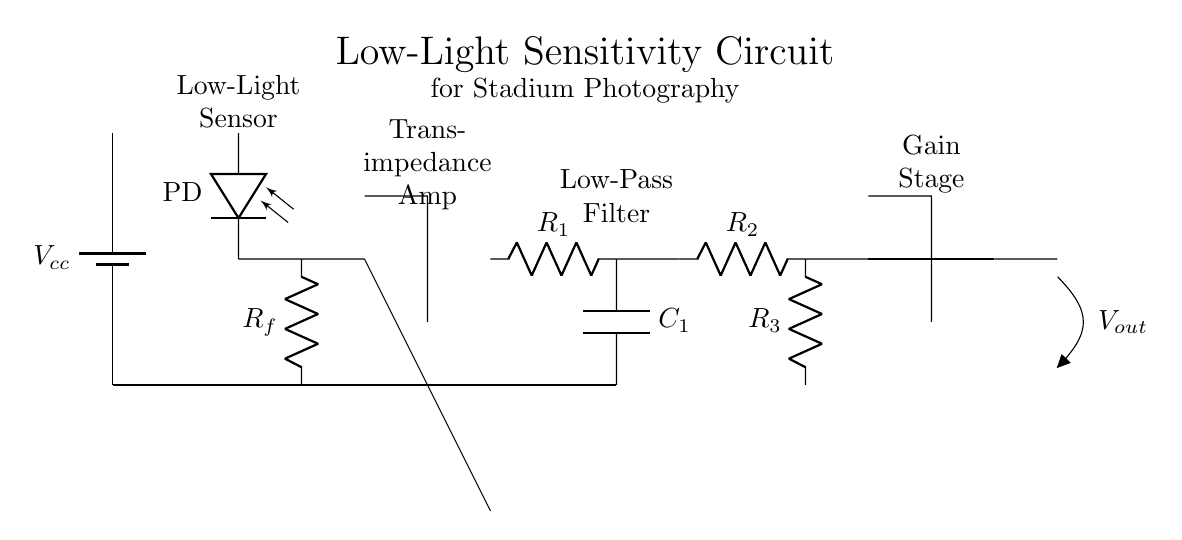What component is used to detect light in this circuit? The component responsible for detecting light is the photodiode, labeled as PD in the diagram. It converts light into an electrical current.
Answer: Photodiode What is the purpose of the transimpedance amplifier? The transimpedance amplifier converts the photocurrent from the photodiode into a voltage signal, amplifying the weak signal to be processed further.
Answer: Signal amplification What are the values of resistors R2 and R3? The diagram specifies resistor R2 and R3 values as R2 in series and R3 in parallel, but exact numeric values are not indicated in the circuit itself. In a well-designed circuit, these values can be calculated based on application requirements.
Answer: Not specified Which stage provides the output voltage? The output voltage is provided by the gain stage, which amplifies the signal further before sending it as an output. It is indicated by the op amp just before the output.
Answer: Gain stage What is the function of the low-pass filter in this circuit? The low-pass filter, consisting of resistor R1 and capacitor C1, is applied to remove high-frequency noise from the signal, allowing only the desired low-frequency component to pass through.
Answer: Noise reduction What is the power supply voltage denoted in the circuit? The power supply voltage is denoted as Vcc at the top of the circuit, indicating the voltage supplied to the entire circuit for operation.
Answer: Vcc How does the output voltage relate to low-light conditions? In low-light conditions, the photocurrent generated by the photodiode is minimal. The transimpedance amplifier enhances this small signal, and the output voltage reflects the faint light levels, allowing for better image capture in dark environments.
Answer: Enhanced output 